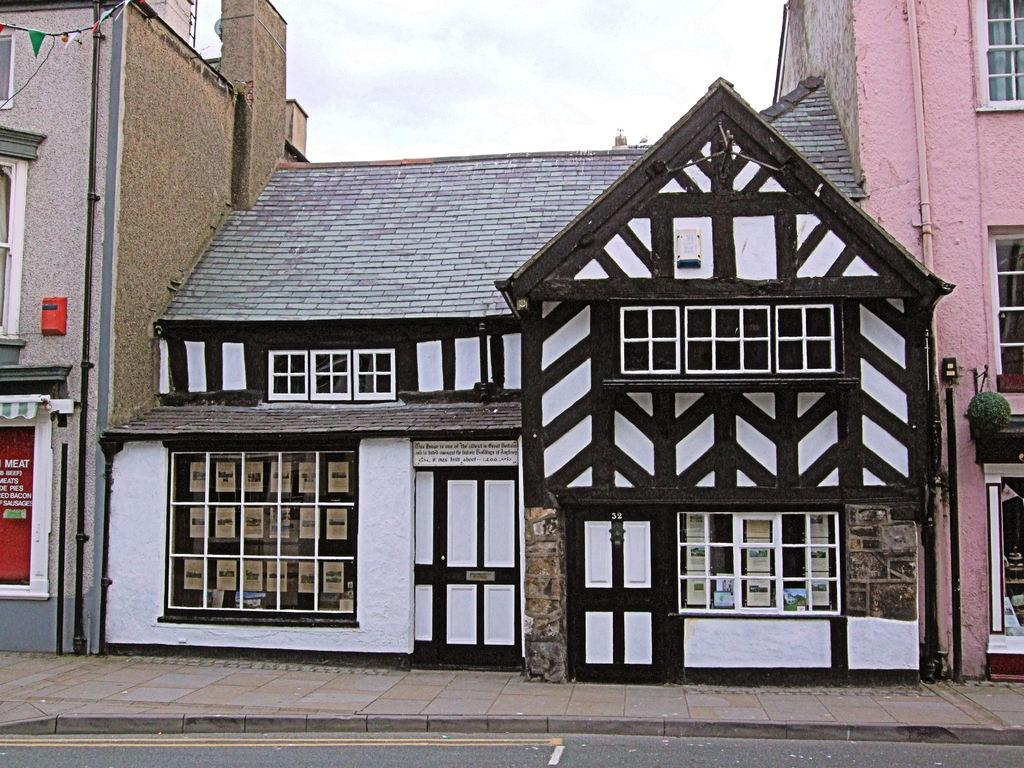What type of path can be seen in the image? There is a footpath in the image. What else is present alongside the footpath? There is a road in the image. What can be seen on the walls or surfaces in the image? There are posters in the image. What type of structures are visible in the image? There are buildings with windows in the image. What else can be seen in the image besides the footpath, road, and posters? There are some objects in the image. What is visible in the background of the image? The sky is visible in the background of the image. Can you tell me how many monkeys are playing with a rake in the image? There are no monkeys or rakes present in the image. What type of dirt can be seen on the footpath in the image? There is no dirt visible on the footpath in the image. 